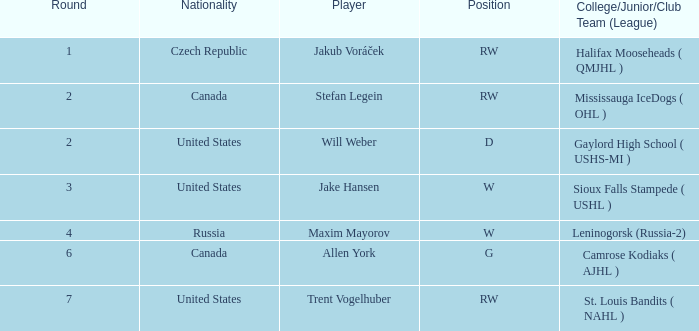What nationality was the round 6 draft pick? Canada. 